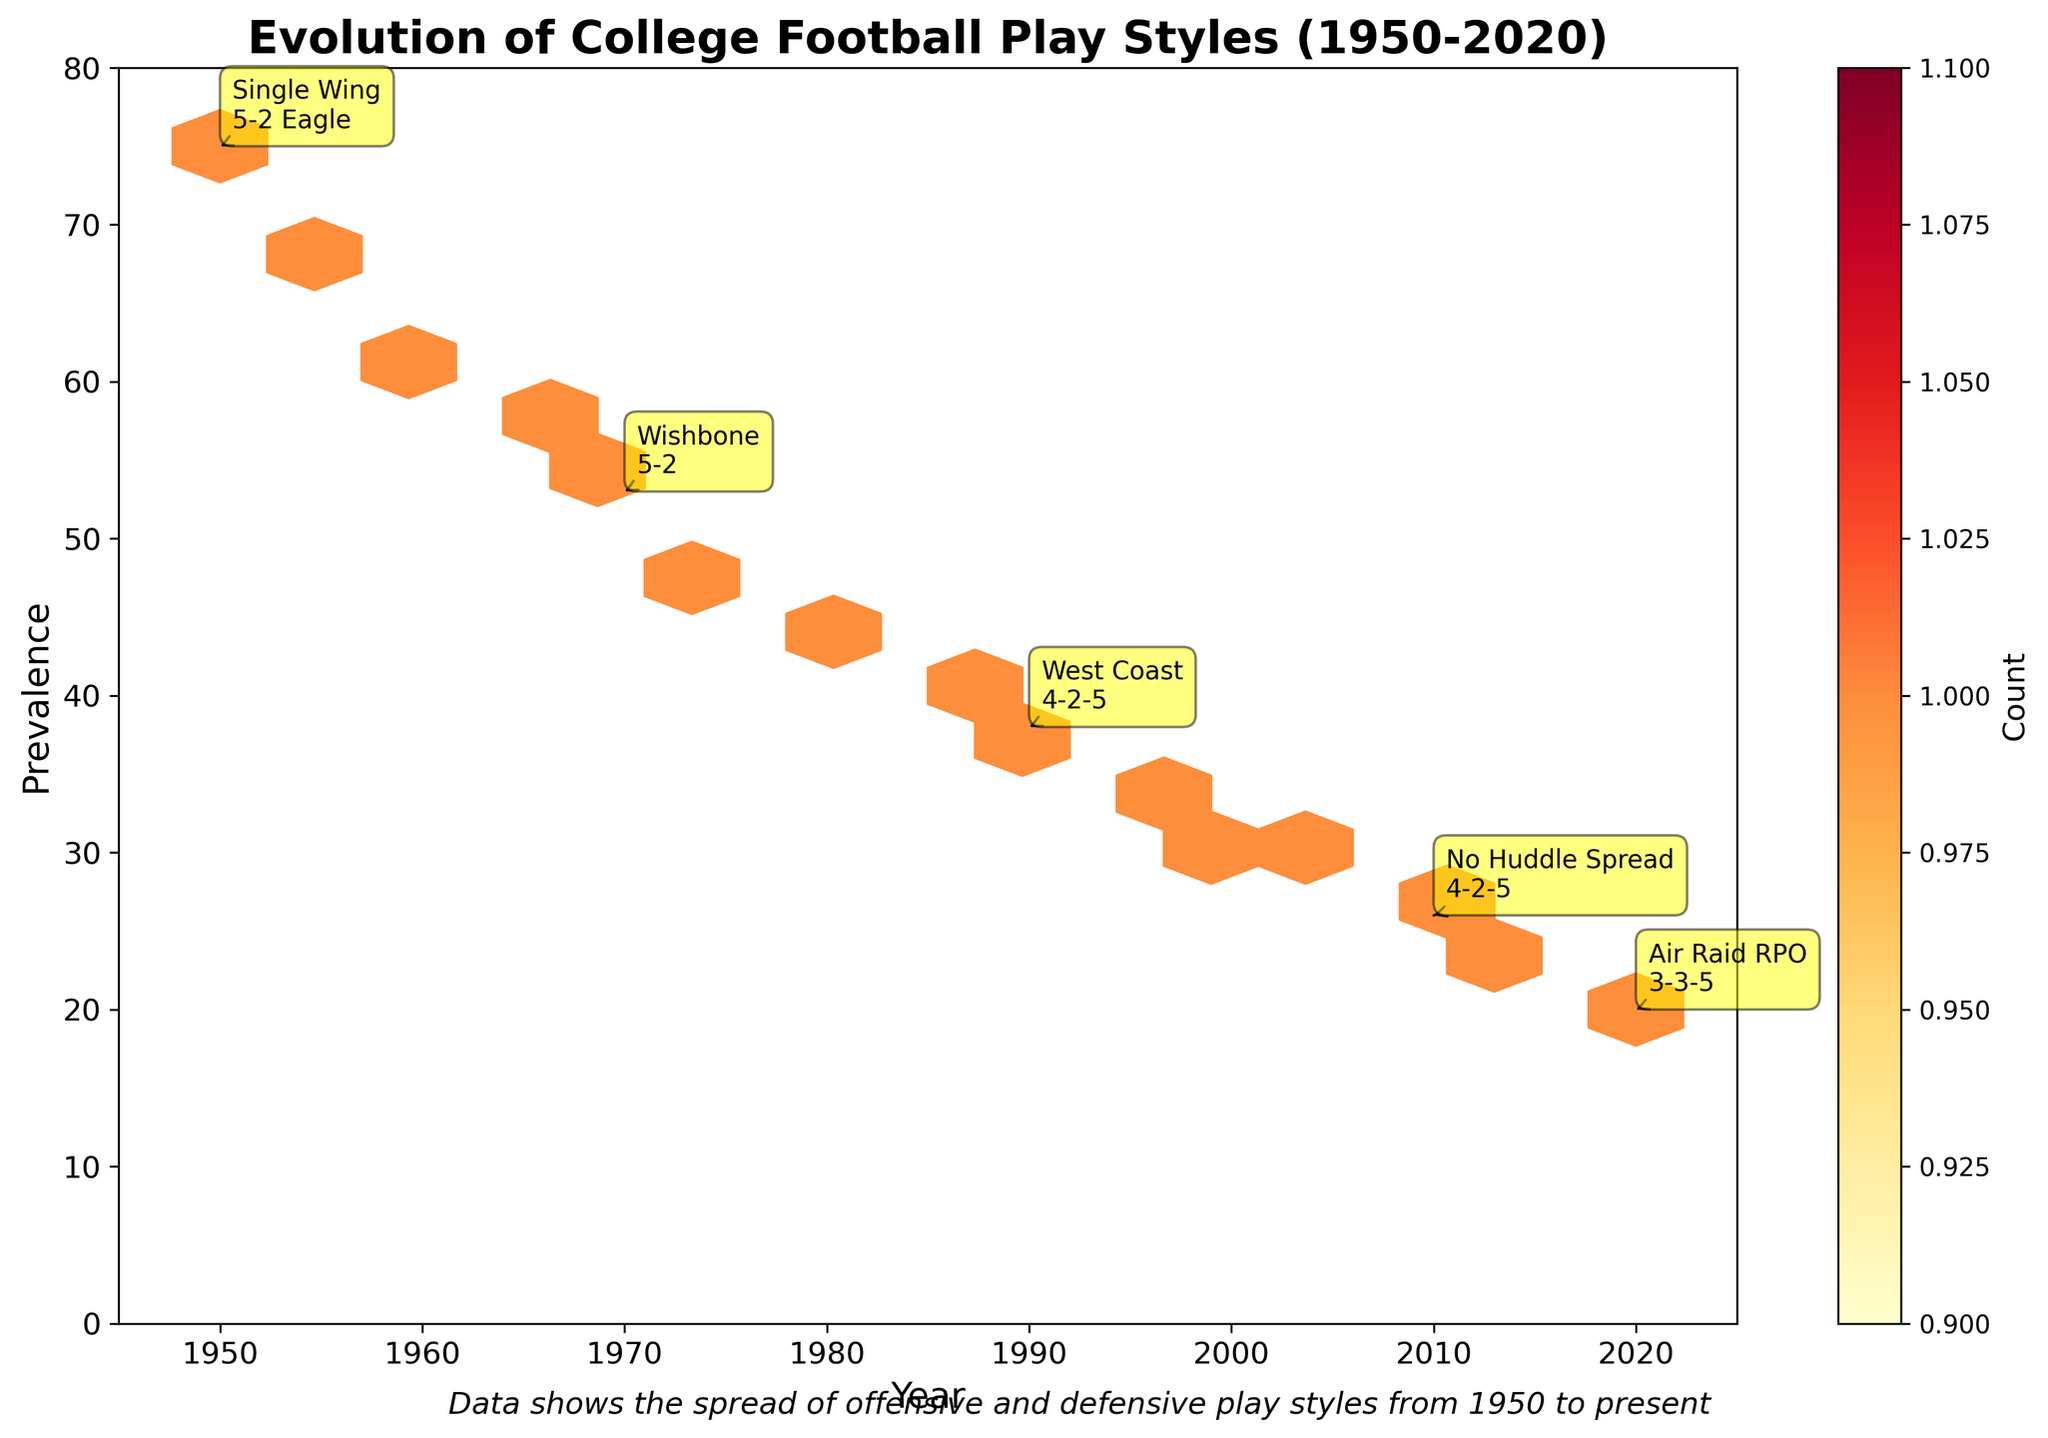What is the title of the hexbin plot? The title is usually located at the top of a plot. In this hexbin plot, you can see it at the top in a bold font.
Answer: Evolution of College Football Play Styles (1950-2020) How many data points are highlighted with annotations in the plot? The annotated points are shown with text and an arrow, making them stand out from the other data points. We can count these annotations directly from the plot.
Answer: 5 What does the color intensity in the hexbin plot represent? The color scale of the hexbin plot, typically shown by the color bar, represents the count of data points within each hexagonal bin. Darker shades indicate higher counts.
Answer: Count Which year shows the highest prevalence of offensive and defensive play styles? To find the year with the highest prevalence, look for the hexbin at the highest y-axis value, which corresponds to 75 in 1950.
Answer: 1950 What is the prevalence of the 'No Huddle Spread' offensive style in 2010? Locate the year 2010 on the x-axis and find its corresponding y-axis value. The annotated text 'No Huddle Spread' is present at the prevalence value.
Answer: 26 Compare the prevalence of the 'Wishbone' in 1970 against the 'Air Raid RPO' in 2020. Which one is higher and by how much? Identify the prevalence for both years: 53 for Wishbone in 1970 and 20 for Air Raid RPO in 2020. Calculate the difference by subtracting the smaller value from the larger one.
Answer: Wishbone by 33 How many years in the data have a prevalence of above 50? By looking at the y-axis and finding hexagons higher than the value 50 and then counting the years corresponding to those data points, we can determine the total number.
Answer: 3 What trends can you observe in the prevalence of play styles from 1950 to 2020? Observing the plot, you can see that the prevalence starts high in 1950 and generally decreases over the years. The color intensity showing fewer high prevalence counts supports this trend.
Answer: Decreasing trend What defensive style is annotated for the year 1990, and what is its prevalence? Locate the year 1990 on the x-axis and find its corresponding annotation to see the defensive style and prevalence marked.
Answer: 4-2-5, 38 Is the prevalence of the 'Run and Shoot' offensive style in 1985 higher than that of the 'West Coast' style in 1990? Compare the y-axis values for the year 1985 (Run and Shoot) and 1990 (West Coast). Run and Shoot has a prevalence of 41, whereas West Coast has 38.
Answer: Yes 